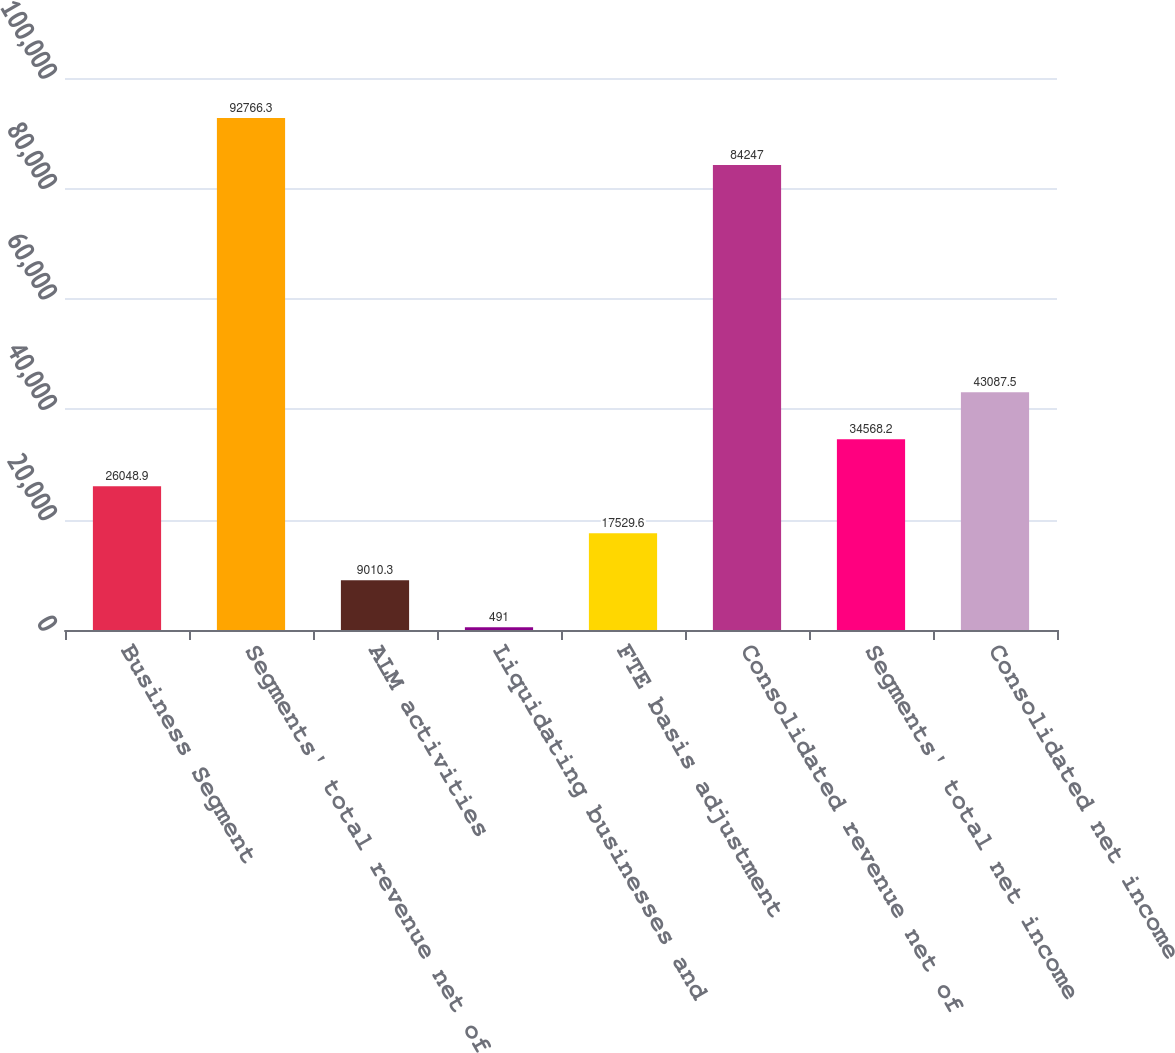<chart> <loc_0><loc_0><loc_500><loc_500><bar_chart><fcel>Business Segment<fcel>Segments' total revenue net of<fcel>ALM activities<fcel>Liquidating businesses and<fcel>FTE basis adjustment<fcel>Consolidated revenue net of<fcel>Segments' total net income<fcel>Consolidated net income<nl><fcel>26048.9<fcel>92766.3<fcel>9010.3<fcel>491<fcel>17529.6<fcel>84247<fcel>34568.2<fcel>43087.5<nl></chart> 